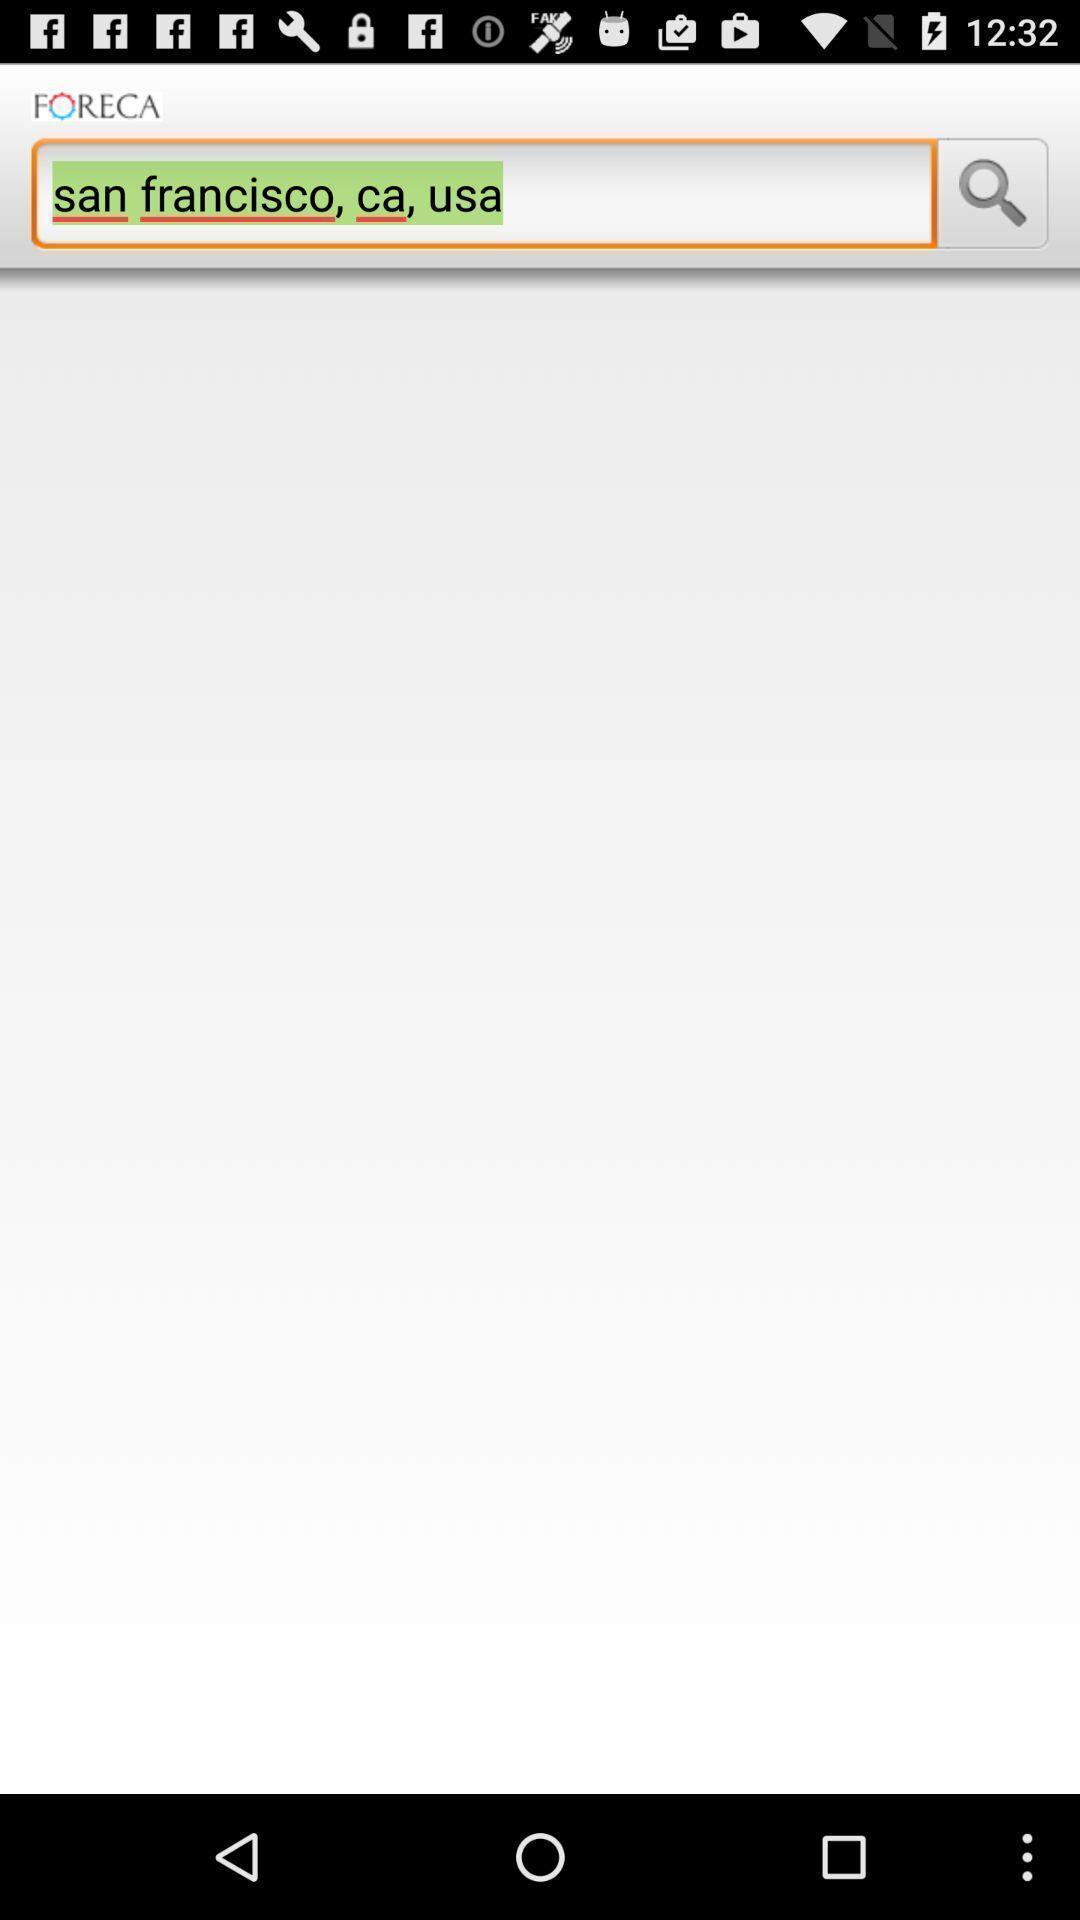Give me a summary of this screen capture. Search page to find location in an weather application. 